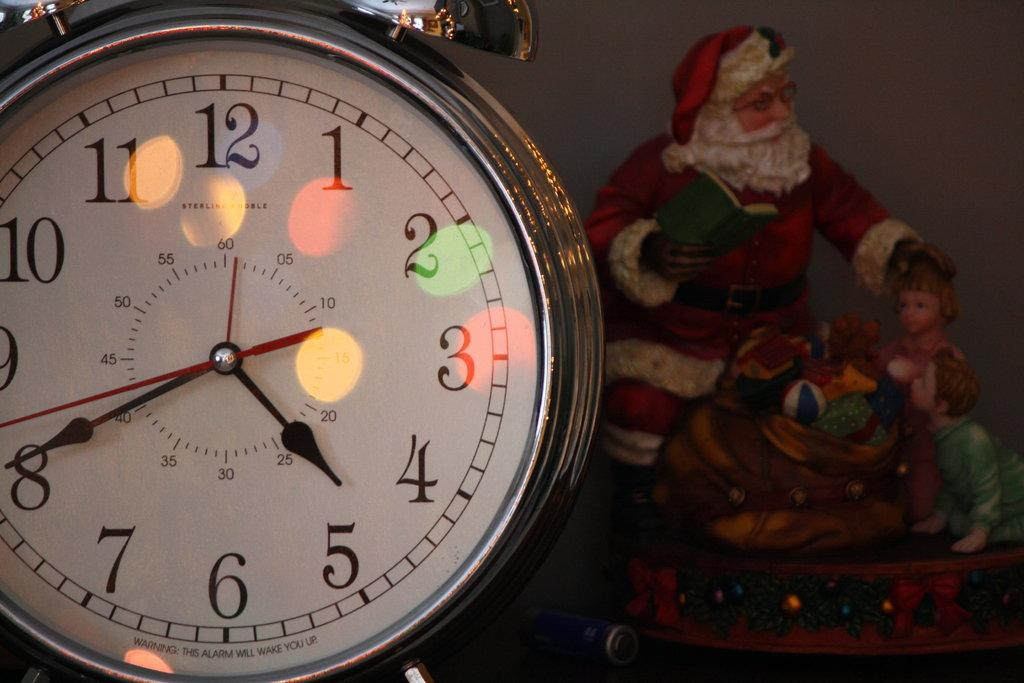<image>
Offer a succinct explanation of the picture presented. A Santa figurine sits next to a clock that has a warning stating that it will wake you up. 